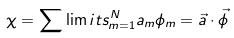Convert formula to latex. <formula><loc_0><loc_0><loc_500><loc_500>\chi = \sum \lim i t s _ { m = 1 } ^ { N } a _ { m } \phi _ { m } = \vec { a } \cdot \vec { \phi }</formula> 